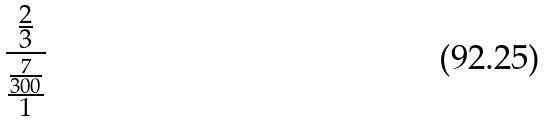Convert formula to latex. <formula><loc_0><loc_0><loc_500><loc_500>\frac { \frac { 2 } { 3 } } { \frac { \frac { 7 } { 3 0 0 } } { 1 } }</formula> 